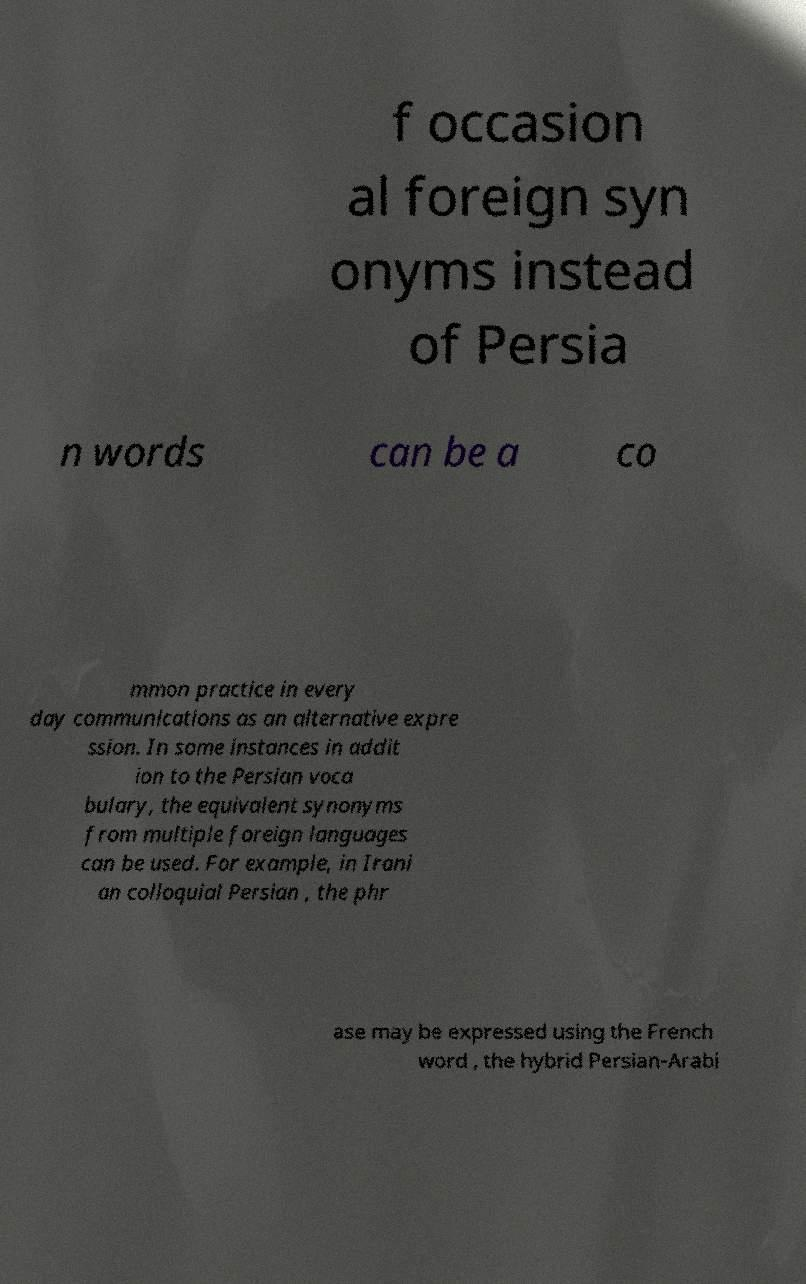Please read and relay the text visible in this image. What does it say? f occasion al foreign syn onyms instead of Persia n words can be a co mmon practice in every day communications as an alternative expre ssion. In some instances in addit ion to the Persian voca bulary, the equivalent synonyms from multiple foreign languages can be used. For example, in Irani an colloquial Persian , the phr ase may be expressed using the French word , the hybrid Persian-Arabi 